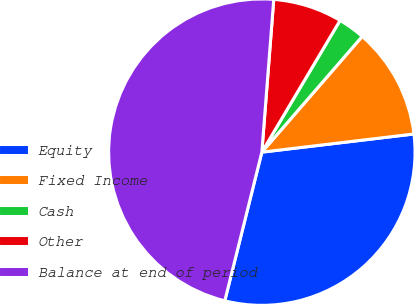Convert chart to OTSL. <chart><loc_0><loc_0><loc_500><loc_500><pie_chart><fcel>Equity<fcel>Fixed Income<fcel>Cash<fcel>Other<fcel>Balance at end of period<nl><fcel>30.78%<fcel>11.74%<fcel>2.84%<fcel>7.29%<fcel>47.35%<nl></chart> 